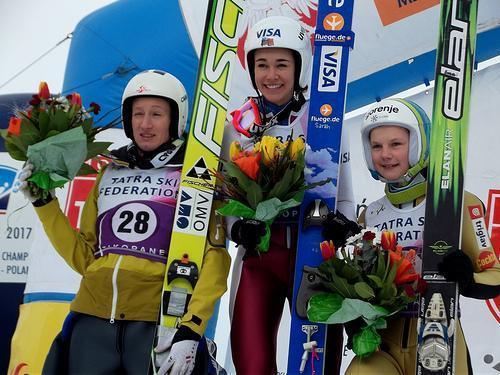How many people are there?
Give a very brief answer. 3. How many people are holding blue skiis?
Give a very brief answer. 1. 